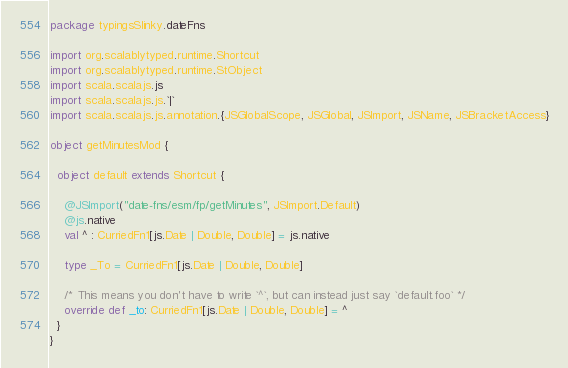Convert code to text. <code><loc_0><loc_0><loc_500><loc_500><_Scala_>package typingsSlinky.dateFns

import org.scalablytyped.runtime.Shortcut
import org.scalablytyped.runtime.StObject
import scala.scalajs.js
import scala.scalajs.js.`|`
import scala.scalajs.js.annotation.{JSGlobalScope, JSGlobal, JSImport, JSName, JSBracketAccess}

object getMinutesMod {
  
  object default extends Shortcut {
    
    @JSImport("date-fns/esm/fp/getMinutes", JSImport.Default)
    @js.native
    val ^ : CurriedFn1[js.Date | Double, Double] = js.native
    
    type _To = CurriedFn1[js.Date | Double, Double]
    
    /* This means you don't have to write `^`, but can instead just say `default.foo` */
    override def _to: CurriedFn1[js.Date | Double, Double] = ^
  }
}
</code> 